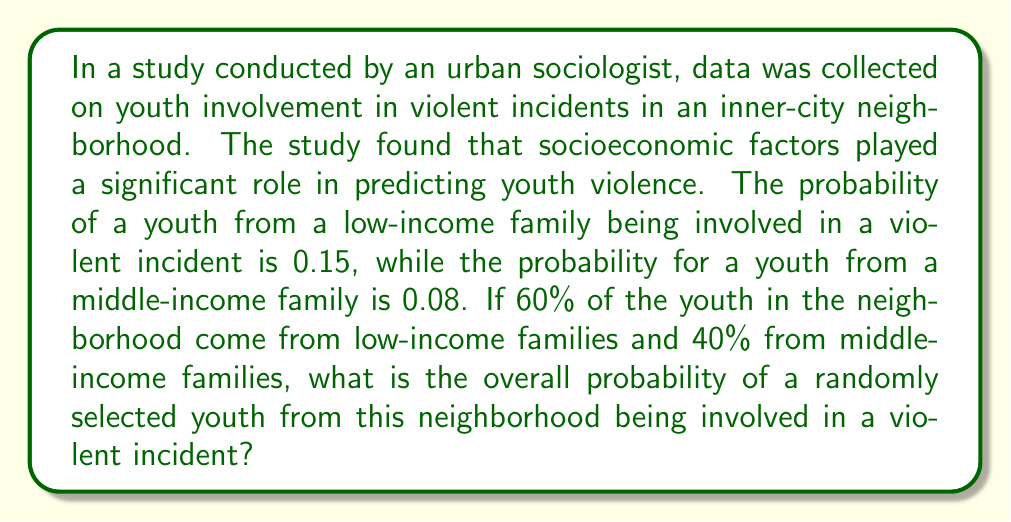Provide a solution to this math problem. To solve this problem, we'll use the law of total probability. Let's break it down step by step:

1. Define our events:
   A: Event that a youth is involved in a violent incident
   L: Event that a youth is from a low-income family
   M: Event that a youth is from a middle-income family

2. Given probabilities:
   P(A|L) = 0.15 (probability of violence given low-income)
   P(A|M) = 0.08 (probability of violence given middle-income)
   P(L) = 0.60 (probability of being from a low-income family)
   P(M) = 0.40 (probability of being from a middle-income family)

3. The law of total probability states:
   $$P(A) = P(A|L) \cdot P(L) + P(A|M) \cdot P(M)$$

4. Substituting the values:
   $$P(A) = 0.15 \cdot 0.60 + 0.08 \cdot 0.40$$

5. Calculating:
   $$P(A) = 0.09 + 0.032 = 0.122$$

Therefore, the overall probability of a randomly selected youth being involved in a violent incident is 0.122 or 12.2%.
Answer: 0.122 or 12.2% 